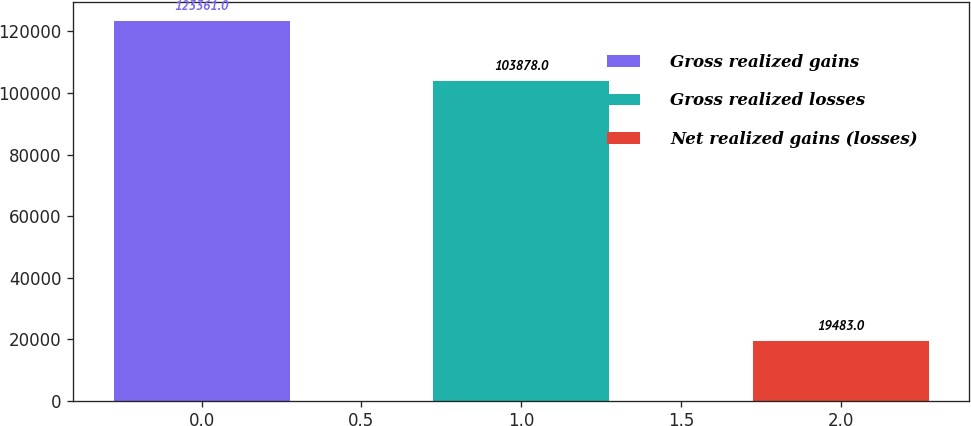Convert chart to OTSL. <chart><loc_0><loc_0><loc_500><loc_500><bar_chart><fcel>Gross realized gains<fcel>Gross realized losses<fcel>Net realized gains (losses)<nl><fcel>123361<fcel>103878<fcel>19483<nl></chart> 